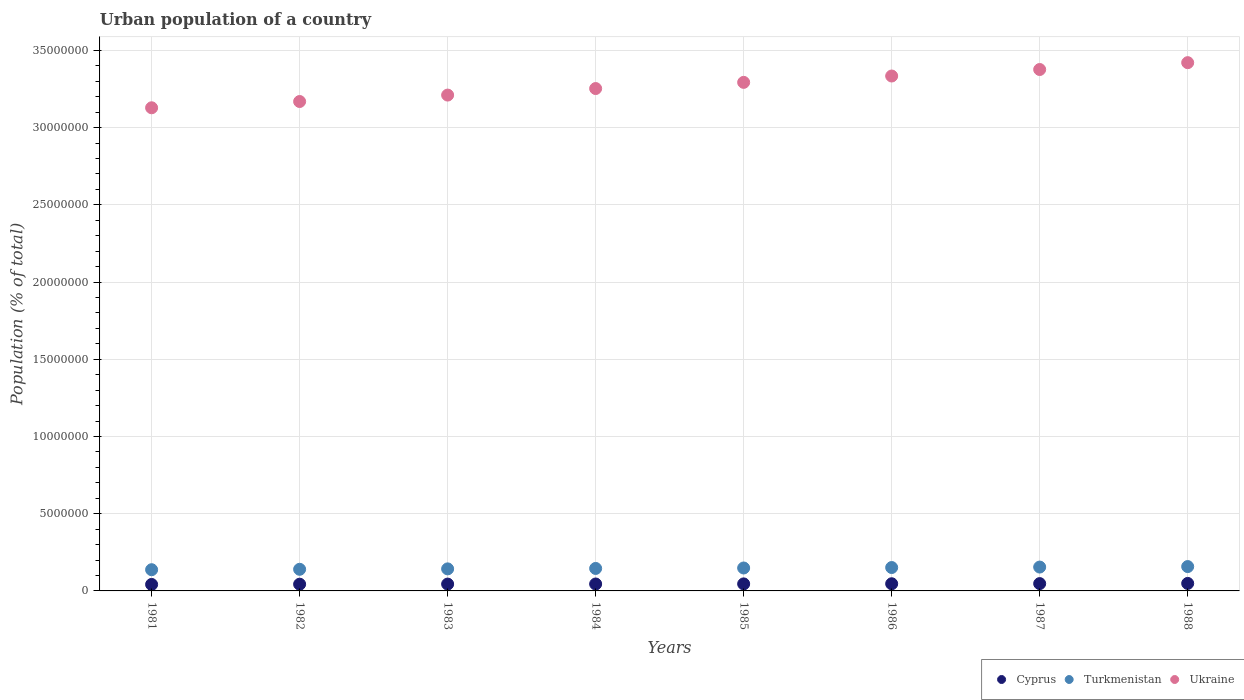How many different coloured dotlines are there?
Your response must be concise. 3. Is the number of dotlines equal to the number of legend labels?
Ensure brevity in your answer.  Yes. What is the urban population in Ukraine in 1985?
Your response must be concise. 3.29e+07. Across all years, what is the maximum urban population in Ukraine?
Your answer should be very brief. 3.42e+07. Across all years, what is the minimum urban population in Ukraine?
Ensure brevity in your answer.  3.13e+07. In which year was the urban population in Turkmenistan maximum?
Make the answer very short. 1988. What is the total urban population in Cyprus in the graph?
Your answer should be compact. 3.62e+06. What is the difference between the urban population in Ukraine in 1982 and that in 1983?
Provide a succinct answer. -4.17e+05. What is the difference between the urban population in Cyprus in 1984 and the urban population in Ukraine in 1988?
Offer a terse response. -3.38e+07. What is the average urban population in Cyprus per year?
Ensure brevity in your answer.  4.53e+05. In the year 1981, what is the difference between the urban population in Cyprus and urban population in Turkmenistan?
Provide a succinct answer. -9.54e+05. What is the ratio of the urban population in Cyprus in 1986 to that in 1988?
Ensure brevity in your answer.  0.95. Is the urban population in Ukraine in 1984 less than that in 1986?
Give a very brief answer. Yes. What is the difference between the highest and the second highest urban population in Ukraine?
Ensure brevity in your answer.  4.43e+05. What is the difference between the highest and the lowest urban population in Ukraine?
Provide a succinct answer. 2.92e+06. Is it the case that in every year, the sum of the urban population in Cyprus and urban population in Turkmenistan  is greater than the urban population in Ukraine?
Provide a short and direct response. No. Does the urban population in Cyprus monotonically increase over the years?
Keep it short and to the point. Yes. How many dotlines are there?
Keep it short and to the point. 3. How many years are there in the graph?
Your answer should be compact. 8. How are the legend labels stacked?
Keep it short and to the point. Horizontal. What is the title of the graph?
Make the answer very short. Urban population of a country. What is the label or title of the X-axis?
Offer a very short reply. Years. What is the label or title of the Y-axis?
Provide a short and direct response. Population (% of total). What is the Population (% of total) in Cyprus in 1981?
Your answer should be very brief. 4.19e+05. What is the Population (% of total) in Turkmenistan in 1981?
Your answer should be very brief. 1.37e+06. What is the Population (% of total) of Ukraine in 1981?
Provide a succinct answer. 3.13e+07. What is the Population (% of total) of Cyprus in 1982?
Ensure brevity in your answer.  4.36e+05. What is the Population (% of total) in Turkmenistan in 1982?
Your response must be concise. 1.40e+06. What is the Population (% of total) of Ukraine in 1982?
Your answer should be compact. 3.17e+07. What is the Population (% of total) of Cyprus in 1983?
Ensure brevity in your answer.  4.43e+05. What is the Population (% of total) in Turkmenistan in 1983?
Offer a terse response. 1.43e+06. What is the Population (% of total) of Ukraine in 1983?
Keep it short and to the point. 3.21e+07. What is the Population (% of total) of Cyprus in 1984?
Make the answer very short. 4.48e+05. What is the Population (% of total) in Turkmenistan in 1984?
Your response must be concise. 1.46e+06. What is the Population (% of total) of Ukraine in 1984?
Your answer should be very brief. 3.25e+07. What is the Population (% of total) of Cyprus in 1985?
Provide a succinct answer. 4.55e+05. What is the Population (% of total) of Turkmenistan in 1985?
Make the answer very short. 1.48e+06. What is the Population (% of total) in Ukraine in 1985?
Offer a terse response. 3.29e+07. What is the Population (% of total) of Cyprus in 1986?
Your answer should be compact. 4.64e+05. What is the Population (% of total) of Turkmenistan in 1986?
Your answer should be compact. 1.51e+06. What is the Population (% of total) in Ukraine in 1986?
Your answer should be very brief. 3.33e+07. What is the Population (% of total) of Cyprus in 1987?
Your answer should be very brief. 4.74e+05. What is the Population (% of total) of Turkmenistan in 1987?
Your answer should be very brief. 1.54e+06. What is the Population (% of total) of Ukraine in 1987?
Provide a short and direct response. 3.38e+07. What is the Population (% of total) of Cyprus in 1988?
Your answer should be compact. 4.86e+05. What is the Population (% of total) of Turkmenistan in 1988?
Keep it short and to the point. 1.58e+06. What is the Population (% of total) in Ukraine in 1988?
Keep it short and to the point. 3.42e+07. Across all years, what is the maximum Population (% of total) of Cyprus?
Offer a very short reply. 4.86e+05. Across all years, what is the maximum Population (% of total) in Turkmenistan?
Give a very brief answer. 1.58e+06. Across all years, what is the maximum Population (% of total) of Ukraine?
Your answer should be compact. 3.42e+07. Across all years, what is the minimum Population (% of total) in Cyprus?
Make the answer very short. 4.19e+05. Across all years, what is the minimum Population (% of total) in Turkmenistan?
Keep it short and to the point. 1.37e+06. Across all years, what is the minimum Population (% of total) of Ukraine?
Ensure brevity in your answer.  3.13e+07. What is the total Population (% of total) of Cyprus in the graph?
Give a very brief answer. 3.62e+06. What is the total Population (% of total) in Turkmenistan in the graph?
Offer a very short reply. 1.18e+07. What is the total Population (% of total) of Ukraine in the graph?
Provide a short and direct response. 2.62e+08. What is the difference between the Population (% of total) in Cyprus in 1981 and that in 1982?
Your answer should be very brief. -1.64e+04. What is the difference between the Population (% of total) of Turkmenistan in 1981 and that in 1982?
Keep it short and to the point. -2.68e+04. What is the difference between the Population (% of total) of Ukraine in 1981 and that in 1982?
Your answer should be very brief. -4.06e+05. What is the difference between the Population (% of total) in Cyprus in 1981 and that in 1983?
Offer a terse response. -2.39e+04. What is the difference between the Population (% of total) of Turkmenistan in 1981 and that in 1983?
Your response must be concise. -5.42e+04. What is the difference between the Population (% of total) of Ukraine in 1981 and that in 1983?
Provide a short and direct response. -8.22e+05. What is the difference between the Population (% of total) of Cyprus in 1981 and that in 1984?
Offer a very short reply. -2.92e+04. What is the difference between the Population (% of total) of Turkmenistan in 1981 and that in 1984?
Ensure brevity in your answer.  -8.22e+04. What is the difference between the Population (% of total) of Ukraine in 1981 and that in 1984?
Provide a short and direct response. -1.25e+06. What is the difference between the Population (% of total) in Cyprus in 1981 and that in 1985?
Keep it short and to the point. -3.61e+04. What is the difference between the Population (% of total) in Turkmenistan in 1981 and that in 1985?
Keep it short and to the point. -1.11e+05. What is the difference between the Population (% of total) of Ukraine in 1981 and that in 1985?
Your answer should be compact. -1.65e+06. What is the difference between the Population (% of total) of Cyprus in 1981 and that in 1986?
Provide a short and direct response. -4.47e+04. What is the difference between the Population (% of total) in Turkmenistan in 1981 and that in 1986?
Your answer should be compact. -1.41e+05. What is the difference between the Population (% of total) in Ukraine in 1981 and that in 1986?
Your response must be concise. -2.06e+06. What is the difference between the Population (% of total) of Cyprus in 1981 and that in 1987?
Provide a succinct answer. -5.49e+04. What is the difference between the Population (% of total) in Turkmenistan in 1981 and that in 1987?
Keep it short and to the point. -1.71e+05. What is the difference between the Population (% of total) in Ukraine in 1981 and that in 1987?
Provide a short and direct response. -2.48e+06. What is the difference between the Population (% of total) of Cyprus in 1981 and that in 1988?
Provide a succinct answer. -6.66e+04. What is the difference between the Population (% of total) of Turkmenistan in 1981 and that in 1988?
Your answer should be compact. -2.03e+05. What is the difference between the Population (% of total) in Ukraine in 1981 and that in 1988?
Offer a terse response. -2.92e+06. What is the difference between the Population (% of total) of Cyprus in 1982 and that in 1983?
Offer a very short reply. -7443. What is the difference between the Population (% of total) in Turkmenistan in 1982 and that in 1983?
Provide a succinct answer. -2.73e+04. What is the difference between the Population (% of total) of Ukraine in 1982 and that in 1983?
Your answer should be compact. -4.17e+05. What is the difference between the Population (% of total) in Cyprus in 1982 and that in 1984?
Your answer should be compact. -1.28e+04. What is the difference between the Population (% of total) of Turkmenistan in 1982 and that in 1984?
Ensure brevity in your answer.  -5.53e+04. What is the difference between the Population (% of total) of Ukraine in 1982 and that in 1984?
Ensure brevity in your answer.  -8.40e+05. What is the difference between the Population (% of total) of Cyprus in 1982 and that in 1985?
Offer a terse response. -1.96e+04. What is the difference between the Population (% of total) in Turkmenistan in 1982 and that in 1985?
Provide a short and direct response. -8.44e+04. What is the difference between the Population (% of total) in Ukraine in 1982 and that in 1985?
Provide a short and direct response. -1.24e+06. What is the difference between the Population (% of total) of Cyprus in 1982 and that in 1986?
Make the answer very short. -2.82e+04. What is the difference between the Population (% of total) in Turkmenistan in 1982 and that in 1986?
Make the answer very short. -1.14e+05. What is the difference between the Population (% of total) of Ukraine in 1982 and that in 1986?
Offer a very short reply. -1.65e+06. What is the difference between the Population (% of total) of Cyprus in 1982 and that in 1987?
Your answer should be very brief. -3.85e+04. What is the difference between the Population (% of total) of Turkmenistan in 1982 and that in 1987?
Make the answer very short. -1.45e+05. What is the difference between the Population (% of total) of Ukraine in 1982 and that in 1987?
Your answer should be very brief. -2.07e+06. What is the difference between the Population (% of total) in Cyprus in 1982 and that in 1988?
Your answer should be very brief. -5.01e+04. What is the difference between the Population (% of total) in Turkmenistan in 1982 and that in 1988?
Offer a terse response. -1.76e+05. What is the difference between the Population (% of total) of Ukraine in 1982 and that in 1988?
Ensure brevity in your answer.  -2.52e+06. What is the difference between the Population (% of total) of Cyprus in 1983 and that in 1984?
Offer a very short reply. -5325. What is the difference between the Population (% of total) in Turkmenistan in 1983 and that in 1984?
Offer a terse response. -2.80e+04. What is the difference between the Population (% of total) in Ukraine in 1983 and that in 1984?
Your answer should be compact. -4.23e+05. What is the difference between the Population (% of total) in Cyprus in 1983 and that in 1985?
Your response must be concise. -1.22e+04. What is the difference between the Population (% of total) in Turkmenistan in 1983 and that in 1985?
Your answer should be very brief. -5.71e+04. What is the difference between the Population (% of total) of Ukraine in 1983 and that in 1985?
Your answer should be compact. -8.23e+05. What is the difference between the Population (% of total) of Cyprus in 1983 and that in 1986?
Give a very brief answer. -2.08e+04. What is the difference between the Population (% of total) in Turkmenistan in 1983 and that in 1986?
Keep it short and to the point. -8.69e+04. What is the difference between the Population (% of total) in Ukraine in 1983 and that in 1986?
Provide a short and direct response. -1.23e+06. What is the difference between the Population (% of total) of Cyprus in 1983 and that in 1987?
Keep it short and to the point. -3.10e+04. What is the difference between the Population (% of total) in Turkmenistan in 1983 and that in 1987?
Ensure brevity in your answer.  -1.17e+05. What is the difference between the Population (% of total) of Ukraine in 1983 and that in 1987?
Provide a short and direct response. -1.66e+06. What is the difference between the Population (% of total) in Cyprus in 1983 and that in 1988?
Provide a succinct answer. -4.27e+04. What is the difference between the Population (% of total) in Turkmenistan in 1983 and that in 1988?
Your answer should be very brief. -1.49e+05. What is the difference between the Population (% of total) of Ukraine in 1983 and that in 1988?
Your answer should be compact. -2.10e+06. What is the difference between the Population (% of total) in Cyprus in 1984 and that in 1985?
Your response must be concise. -6838. What is the difference between the Population (% of total) of Turkmenistan in 1984 and that in 1985?
Provide a short and direct response. -2.90e+04. What is the difference between the Population (% of total) in Ukraine in 1984 and that in 1985?
Give a very brief answer. -4.00e+05. What is the difference between the Population (% of total) of Cyprus in 1984 and that in 1986?
Give a very brief answer. -1.55e+04. What is the difference between the Population (% of total) of Turkmenistan in 1984 and that in 1986?
Provide a succinct answer. -5.88e+04. What is the difference between the Population (% of total) in Ukraine in 1984 and that in 1986?
Give a very brief answer. -8.12e+05. What is the difference between the Population (% of total) in Cyprus in 1984 and that in 1987?
Your answer should be very brief. -2.57e+04. What is the difference between the Population (% of total) in Turkmenistan in 1984 and that in 1987?
Keep it short and to the point. -8.92e+04. What is the difference between the Population (% of total) of Ukraine in 1984 and that in 1987?
Ensure brevity in your answer.  -1.23e+06. What is the difference between the Population (% of total) in Cyprus in 1984 and that in 1988?
Provide a short and direct response. -3.74e+04. What is the difference between the Population (% of total) in Turkmenistan in 1984 and that in 1988?
Make the answer very short. -1.21e+05. What is the difference between the Population (% of total) of Ukraine in 1984 and that in 1988?
Your answer should be very brief. -1.68e+06. What is the difference between the Population (% of total) of Cyprus in 1985 and that in 1986?
Your answer should be very brief. -8613. What is the difference between the Population (% of total) in Turkmenistan in 1985 and that in 1986?
Your answer should be very brief. -2.98e+04. What is the difference between the Population (% of total) in Ukraine in 1985 and that in 1986?
Offer a very short reply. -4.11e+05. What is the difference between the Population (% of total) of Cyprus in 1985 and that in 1987?
Provide a short and direct response. -1.89e+04. What is the difference between the Population (% of total) of Turkmenistan in 1985 and that in 1987?
Your response must be concise. -6.02e+04. What is the difference between the Population (% of total) of Ukraine in 1985 and that in 1987?
Offer a terse response. -8.33e+05. What is the difference between the Population (% of total) of Cyprus in 1985 and that in 1988?
Provide a short and direct response. -3.05e+04. What is the difference between the Population (% of total) of Turkmenistan in 1985 and that in 1988?
Keep it short and to the point. -9.18e+04. What is the difference between the Population (% of total) in Ukraine in 1985 and that in 1988?
Your answer should be very brief. -1.28e+06. What is the difference between the Population (% of total) in Cyprus in 1986 and that in 1987?
Your response must be concise. -1.02e+04. What is the difference between the Population (% of total) of Turkmenistan in 1986 and that in 1987?
Your answer should be compact. -3.04e+04. What is the difference between the Population (% of total) of Ukraine in 1986 and that in 1987?
Keep it short and to the point. -4.21e+05. What is the difference between the Population (% of total) of Cyprus in 1986 and that in 1988?
Keep it short and to the point. -2.19e+04. What is the difference between the Population (% of total) of Turkmenistan in 1986 and that in 1988?
Offer a very short reply. -6.20e+04. What is the difference between the Population (% of total) of Ukraine in 1986 and that in 1988?
Provide a succinct answer. -8.65e+05. What is the difference between the Population (% of total) of Cyprus in 1987 and that in 1988?
Keep it short and to the point. -1.17e+04. What is the difference between the Population (% of total) of Turkmenistan in 1987 and that in 1988?
Provide a short and direct response. -3.16e+04. What is the difference between the Population (% of total) in Ukraine in 1987 and that in 1988?
Offer a very short reply. -4.43e+05. What is the difference between the Population (% of total) in Cyprus in 1981 and the Population (% of total) in Turkmenistan in 1982?
Your response must be concise. -9.81e+05. What is the difference between the Population (% of total) of Cyprus in 1981 and the Population (% of total) of Ukraine in 1982?
Offer a very short reply. -3.13e+07. What is the difference between the Population (% of total) of Turkmenistan in 1981 and the Population (% of total) of Ukraine in 1982?
Your response must be concise. -3.03e+07. What is the difference between the Population (% of total) of Cyprus in 1981 and the Population (% of total) of Turkmenistan in 1983?
Offer a very short reply. -1.01e+06. What is the difference between the Population (% of total) in Cyprus in 1981 and the Population (% of total) in Ukraine in 1983?
Your response must be concise. -3.17e+07. What is the difference between the Population (% of total) of Turkmenistan in 1981 and the Population (% of total) of Ukraine in 1983?
Your answer should be very brief. -3.07e+07. What is the difference between the Population (% of total) in Cyprus in 1981 and the Population (% of total) in Turkmenistan in 1984?
Offer a terse response. -1.04e+06. What is the difference between the Population (% of total) in Cyprus in 1981 and the Population (% of total) in Ukraine in 1984?
Your answer should be very brief. -3.21e+07. What is the difference between the Population (% of total) in Turkmenistan in 1981 and the Population (% of total) in Ukraine in 1984?
Ensure brevity in your answer.  -3.12e+07. What is the difference between the Population (% of total) in Cyprus in 1981 and the Population (% of total) in Turkmenistan in 1985?
Your answer should be very brief. -1.07e+06. What is the difference between the Population (% of total) of Cyprus in 1981 and the Population (% of total) of Ukraine in 1985?
Give a very brief answer. -3.25e+07. What is the difference between the Population (% of total) of Turkmenistan in 1981 and the Population (% of total) of Ukraine in 1985?
Provide a short and direct response. -3.16e+07. What is the difference between the Population (% of total) in Cyprus in 1981 and the Population (% of total) in Turkmenistan in 1986?
Provide a short and direct response. -1.10e+06. What is the difference between the Population (% of total) in Cyprus in 1981 and the Population (% of total) in Ukraine in 1986?
Provide a short and direct response. -3.29e+07. What is the difference between the Population (% of total) of Turkmenistan in 1981 and the Population (% of total) of Ukraine in 1986?
Provide a short and direct response. -3.20e+07. What is the difference between the Population (% of total) of Cyprus in 1981 and the Population (% of total) of Turkmenistan in 1987?
Your answer should be compact. -1.13e+06. What is the difference between the Population (% of total) in Cyprus in 1981 and the Population (% of total) in Ukraine in 1987?
Your answer should be compact. -3.33e+07. What is the difference between the Population (% of total) of Turkmenistan in 1981 and the Population (% of total) of Ukraine in 1987?
Provide a short and direct response. -3.24e+07. What is the difference between the Population (% of total) of Cyprus in 1981 and the Population (% of total) of Turkmenistan in 1988?
Your answer should be very brief. -1.16e+06. What is the difference between the Population (% of total) of Cyprus in 1981 and the Population (% of total) of Ukraine in 1988?
Offer a terse response. -3.38e+07. What is the difference between the Population (% of total) of Turkmenistan in 1981 and the Population (% of total) of Ukraine in 1988?
Keep it short and to the point. -3.28e+07. What is the difference between the Population (% of total) of Cyprus in 1982 and the Population (% of total) of Turkmenistan in 1983?
Offer a terse response. -9.92e+05. What is the difference between the Population (% of total) of Cyprus in 1982 and the Population (% of total) of Ukraine in 1983?
Your answer should be compact. -3.17e+07. What is the difference between the Population (% of total) in Turkmenistan in 1982 and the Population (% of total) in Ukraine in 1983?
Your answer should be very brief. -3.07e+07. What is the difference between the Population (% of total) of Cyprus in 1982 and the Population (% of total) of Turkmenistan in 1984?
Offer a very short reply. -1.02e+06. What is the difference between the Population (% of total) in Cyprus in 1982 and the Population (% of total) in Ukraine in 1984?
Provide a succinct answer. -3.21e+07. What is the difference between the Population (% of total) in Turkmenistan in 1982 and the Population (% of total) in Ukraine in 1984?
Make the answer very short. -3.11e+07. What is the difference between the Population (% of total) of Cyprus in 1982 and the Population (% of total) of Turkmenistan in 1985?
Offer a terse response. -1.05e+06. What is the difference between the Population (% of total) of Cyprus in 1982 and the Population (% of total) of Ukraine in 1985?
Give a very brief answer. -3.25e+07. What is the difference between the Population (% of total) of Turkmenistan in 1982 and the Population (% of total) of Ukraine in 1985?
Provide a succinct answer. -3.15e+07. What is the difference between the Population (% of total) of Cyprus in 1982 and the Population (% of total) of Turkmenistan in 1986?
Keep it short and to the point. -1.08e+06. What is the difference between the Population (% of total) in Cyprus in 1982 and the Population (% of total) in Ukraine in 1986?
Provide a succinct answer. -3.29e+07. What is the difference between the Population (% of total) of Turkmenistan in 1982 and the Population (% of total) of Ukraine in 1986?
Offer a very short reply. -3.19e+07. What is the difference between the Population (% of total) in Cyprus in 1982 and the Population (% of total) in Turkmenistan in 1987?
Your response must be concise. -1.11e+06. What is the difference between the Population (% of total) in Cyprus in 1982 and the Population (% of total) in Ukraine in 1987?
Offer a terse response. -3.33e+07. What is the difference between the Population (% of total) in Turkmenistan in 1982 and the Population (% of total) in Ukraine in 1987?
Offer a very short reply. -3.24e+07. What is the difference between the Population (% of total) of Cyprus in 1982 and the Population (% of total) of Turkmenistan in 1988?
Your answer should be very brief. -1.14e+06. What is the difference between the Population (% of total) in Cyprus in 1982 and the Population (% of total) in Ukraine in 1988?
Your answer should be compact. -3.38e+07. What is the difference between the Population (% of total) of Turkmenistan in 1982 and the Population (% of total) of Ukraine in 1988?
Your response must be concise. -3.28e+07. What is the difference between the Population (% of total) in Cyprus in 1983 and the Population (% of total) in Turkmenistan in 1984?
Your answer should be compact. -1.01e+06. What is the difference between the Population (% of total) of Cyprus in 1983 and the Population (% of total) of Ukraine in 1984?
Your answer should be very brief. -3.21e+07. What is the difference between the Population (% of total) in Turkmenistan in 1983 and the Population (% of total) in Ukraine in 1984?
Keep it short and to the point. -3.11e+07. What is the difference between the Population (% of total) of Cyprus in 1983 and the Population (% of total) of Turkmenistan in 1985?
Your response must be concise. -1.04e+06. What is the difference between the Population (% of total) in Cyprus in 1983 and the Population (% of total) in Ukraine in 1985?
Offer a very short reply. -3.25e+07. What is the difference between the Population (% of total) in Turkmenistan in 1983 and the Population (% of total) in Ukraine in 1985?
Offer a very short reply. -3.15e+07. What is the difference between the Population (% of total) in Cyprus in 1983 and the Population (% of total) in Turkmenistan in 1986?
Offer a terse response. -1.07e+06. What is the difference between the Population (% of total) in Cyprus in 1983 and the Population (% of total) in Ukraine in 1986?
Your answer should be very brief. -3.29e+07. What is the difference between the Population (% of total) of Turkmenistan in 1983 and the Population (% of total) of Ukraine in 1986?
Provide a short and direct response. -3.19e+07. What is the difference between the Population (% of total) of Cyprus in 1983 and the Population (% of total) of Turkmenistan in 1987?
Keep it short and to the point. -1.10e+06. What is the difference between the Population (% of total) of Cyprus in 1983 and the Population (% of total) of Ukraine in 1987?
Offer a terse response. -3.33e+07. What is the difference between the Population (% of total) in Turkmenistan in 1983 and the Population (% of total) in Ukraine in 1987?
Give a very brief answer. -3.23e+07. What is the difference between the Population (% of total) of Cyprus in 1983 and the Population (% of total) of Turkmenistan in 1988?
Offer a terse response. -1.13e+06. What is the difference between the Population (% of total) in Cyprus in 1983 and the Population (% of total) in Ukraine in 1988?
Give a very brief answer. -3.38e+07. What is the difference between the Population (% of total) in Turkmenistan in 1983 and the Population (% of total) in Ukraine in 1988?
Your response must be concise. -3.28e+07. What is the difference between the Population (% of total) in Cyprus in 1984 and the Population (% of total) in Turkmenistan in 1985?
Offer a terse response. -1.04e+06. What is the difference between the Population (% of total) of Cyprus in 1984 and the Population (% of total) of Ukraine in 1985?
Give a very brief answer. -3.25e+07. What is the difference between the Population (% of total) of Turkmenistan in 1984 and the Population (% of total) of Ukraine in 1985?
Provide a short and direct response. -3.15e+07. What is the difference between the Population (% of total) of Cyprus in 1984 and the Population (% of total) of Turkmenistan in 1986?
Provide a succinct answer. -1.07e+06. What is the difference between the Population (% of total) of Cyprus in 1984 and the Population (% of total) of Ukraine in 1986?
Your answer should be compact. -3.29e+07. What is the difference between the Population (% of total) of Turkmenistan in 1984 and the Population (% of total) of Ukraine in 1986?
Ensure brevity in your answer.  -3.19e+07. What is the difference between the Population (% of total) in Cyprus in 1984 and the Population (% of total) in Turkmenistan in 1987?
Offer a terse response. -1.10e+06. What is the difference between the Population (% of total) in Cyprus in 1984 and the Population (% of total) in Ukraine in 1987?
Give a very brief answer. -3.33e+07. What is the difference between the Population (% of total) in Turkmenistan in 1984 and the Population (% of total) in Ukraine in 1987?
Your answer should be very brief. -3.23e+07. What is the difference between the Population (% of total) of Cyprus in 1984 and the Population (% of total) of Turkmenistan in 1988?
Your answer should be very brief. -1.13e+06. What is the difference between the Population (% of total) in Cyprus in 1984 and the Population (% of total) in Ukraine in 1988?
Your answer should be very brief. -3.38e+07. What is the difference between the Population (% of total) of Turkmenistan in 1984 and the Population (% of total) of Ukraine in 1988?
Provide a short and direct response. -3.28e+07. What is the difference between the Population (% of total) of Cyprus in 1985 and the Population (% of total) of Turkmenistan in 1986?
Provide a succinct answer. -1.06e+06. What is the difference between the Population (% of total) in Cyprus in 1985 and the Population (% of total) in Ukraine in 1986?
Give a very brief answer. -3.29e+07. What is the difference between the Population (% of total) of Turkmenistan in 1985 and the Population (% of total) of Ukraine in 1986?
Your answer should be very brief. -3.19e+07. What is the difference between the Population (% of total) in Cyprus in 1985 and the Population (% of total) in Turkmenistan in 1987?
Make the answer very short. -1.09e+06. What is the difference between the Population (% of total) in Cyprus in 1985 and the Population (% of total) in Ukraine in 1987?
Your response must be concise. -3.33e+07. What is the difference between the Population (% of total) in Turkmenistan in 1985 and the Population (% of total) in Ukraine in 1987?
Keep it short and to the point. -3.23e+07. What is the difference between the Population (% of total) in Cyprus in 1985 and the Population (% of total) in Turkmenistan in 1988?
Ensure brevity in your answer.  -1.12e+06. What is the difference between the Population (% of total) in Cyprus in 1985 and the Population (% of total) in Ukraine in 1988?
Give a very brief answer. -3.38e+07. What is the difference between the Population (% of total) in Turkmenistan in 1985 and the Population (% of total) in Ukraine in 1988?
Provide a short and direct response. -3.27e+07. What is the difference between the Population (% of total) in Cyprus in 1986 and the Population (% of total) in Turkmenistan in 1987?
Provide a succinct answer. -1.08e+06. What is the difference between the Population (% of total) of Cyprus in 1986 and the Population (% of total) of Ukraine in 1987?
Give a very brief answer. -3.33e+07. What is the difference between the Population (% of total) of Turkmenistan in 1986 and the Population (% of total) of Ukraine in 1987?
Provide a succinct answer. -3.23e+07. What is the difference between the Population (% of total) in Cyprus in 1986 and the Population (% of total) in Turkmenistan in 1988?
Keep it short and to the point. -1.11e+06. What is the difference between the Population (% of total) of Cyprus in 1986 and the Population (% of total) of Ukraine in 1988?
Offer a terse response. -3.37e+07. What is the difference between the Population (% of total) of Turkmenistan in 1986 and the Population (% of total) of Ukraine in 1988?
Ensure brevity in your answer.  -3.27e+07. What is the difference between the Population (% of total) of Cyprus in 1987 and the Population (% of total) of Turkmenistan in 1988?
Ensure brevity in your answer.  -1.10e+06. What is the difference between the Population (% of total) of Cyprus in 1987 and the Population (% of total) of Ukraine in 1988?
Make the answer very short. -3.37e+07. What is the difference between the Population (% of total) of Turkmenistan in 1987 and the Population (% of total) of Ukraine in 1988?
Give a very brief answer. -3.27e+07. What is the average Population (% of total) in Cyprus per year?
Give a very brief answer. 4.53e+05. What is the average Population (% of total) of Turkmenistan per year?
Offer a very short reply. 1.47e+06. What is the average Population (% of total) in Ukraine per year?
Provide a short and direct response. 3.27e+07. In the year 1981, what is the difference between the Population (% of total) in Cyprus and Population (% of total) in Turkmenistan?
Ensure brevity in your answer.  -9.54e+05. In the year 1981, what is the difference between the Population (% of total) in Cyprus and Population (% of total) in Ukraine?
Provide a succinct answer. -3.09e+07. In the year 1981, what is the difference between the Population (% of total) in Turkmenistan and Population (% of total) in Ukraine?
Your response must be concise. -2.99e+07. In the year 1982, what is the difference between the Population (% of total) in Cyprus and Population (% of total) in Turkmenistan?
Provide a short and direct response. -9.65e+05. In the year 1982, what is the difference between the Population (% of total) of Cyprus and Population (% of total) of Ukraine?
Give a very brief answer. -3.13e+07. In the year 1982, what is the difference between the Population (% of total) of Turkmenistan and Population (% of total) of Ukraine?
Offer a very short reply. -3.03e+07. In the year 1983, what is the difference between the Population (% of total) in Cyprus and Population (% of total) in Turkmenistan?
Offer a terse response. -9.85e+05. In the year 1983, what is the difference between the Population (% of total) in Cyprus and Population (% of total) in Ukraine?
Keep it short and to the point. -3.17e+07. In the year 1983, what is the difference between the Population (% of total) in Turkmenistan and Population (% of total) in Ukraine?
Your response must be concise. -3.07e+07. In the year 1984, what is the difference between the Population (% of total) in Cyprus and Population (% of total) in Turkmenistan?
Your answer should be very brief. -1.01e+06. In the year 1984, what is the difference between the Population (% of total) in Cyprus and Population (% of total) in Ukraine?
Ensure brevity in your answer.  -3.21e+07. In the year 1984, what is the difference between the Population (% of total) of Turkmenistan and Population (% of total) of Ukraine?
Provide a succinct answer. -3.11e+07. In the year 1985, what is the difference between the Population (% of total) of Cyprus and Population (% of total) of Turkmenistan?
Your answer should be very brief. -1.03e+06. In the year 1985, what is the difference between the Population (% of total) of Cyprus and Population (% of total) of Ukraine?
Offer a terse response. -3.25e+07. In the year 1985, what is the difference between the Population (% of total) of Turkmenistan and Population (% of total) of Ukraine?
Provide a succinct answer. -3.14e+07. In the year 1986, what is the difference between the Population (% of total) in Cyprus and Population (% of total) in Turkmenistan?
Offer a terse response. -1.05e+06. In the year 1986, what is the difference between the Population (% of total) in Cyprus and Population (% of total) in Ukraine?
Your response must be concise. -3.29e+07. In the year 1986, what is the difference between the Population (% of total) of Turkmenistan and Population (% of total) of Ukraine?
Ensure brevity in your answer.  -3.18e+07. In the year 1987, what is the difference between the Population (% of total) of Cyprus and Population (% of total) of Turkmenistan?
Your answer should be compact. -1.07e+06. In the year 1987, what is the difference between the Population (% of total) of Cyprus and Population (% of total) of Ukraine?
Offer a terse response. -3.33e+07. In the year 1987, what is the difference between the Population (% of total) of Turkmenistan and Population (% of total) of Ukraine?
Your response must be concise. -3.22e+07. In the year 1988, what is the difference between the Population (% of total) of Cyprus and Population (% of total) of Turkmenistan?
Your response must be concise. -1.09e+06. In the year 1988, what is the difference between the Population (% of total) in Cyprus and Population (% of total) in Ukraine?
Your answer should be very brief. -3.37e+07. In the year 1988, what is the difference between the Population (% of total) in Turkmenistan and Population (% of total) in Ukraine?
Give a very brief answer. -3.26e+07. What is the ratio of the Population (% of total) in Cyprus in 1981 to that in 1982?
Your answer should be very brief. 0.96. What is the ratio of the Population (% of total) of Turkmenistan in 1981 to that in 1982?
Offer a very short reply. 0.98. What is the ratio of the Population (% of total) in Ukraine in 1981 to that in 1982?
Give a very brief answer. 0.99. What is the ratio of the Population (% of total) in Cyprus in 1981 to that in 1983?
Keep it short and to the point. 0.95. What is the ratio of the Population (% of total) in Turkmenistan in 1981 to that in 1983?
Your answer should be very brief. 0.96. What is the ratio of the Population (% of total) in Ukraine in 1981 to that in 1983?
Your answer should be very brief. 0.97. What is the ratio of the Population (% of total) of Cyprus in 1981 to that in 1984?
Your answer should be compact. 0.93. What is the ratio of the Population (% of total) in Turkmenistan in 1981 to that in 1984?
Make the answer very short. 0.94. What is the ratio of the Population (% of total) in Ukraine in 1981 to that in 1984?
Provide a succinct answer. 0.96. What is the ratio of the Population (% of total) in Cyprus in 1981 to that in 1985?
Your answer should be very brief. 0.92. What is the ratio of the Population (% of total) of Turkmenistan in 1981 to that in 1985?
Make the answer very short. 0.93. What is the ratio of the Population (% of total) in Cyprus in 1981 to that in 1986?
Ensure brevity in your answer.  0.9. What is the ratio of the Population (% of total) in Turkmenistan in 1981 to that in 1986?
Make the answer very short. 0.91. What is the ratio of the Population (% of total) in Ukraine in 1981 to that in 1986?
Offer a terse response. 0.94. What is the ratio of the Population (% of total) in Cyprus in 1981 to that in 1987?
Offer a terse response. 0.88. What is the ratio of the Population (% of total) in Turkmenistan in 1981 to that in 1987?
Provide a succinct answer. 0.89. What is the ratio of the Population (% of total) in Ukraine in 1981 to that in 1987?
Provide a short and direct response. 0.93. What is the ratio of the Population (% of total) in Cyprus in 1981 to that in 1988?
Offer a very short reply. 0.86. What is the ratio of the Population (% of total) of Turkmenistan in 1981 to that in 1988?
Offer a very short reply. 0.87. What is the ratio of the Population (% of total) of Ukraine in 1981 to that in 1988?
Your response must be concise. 0.91. What is the ratio of the Population (% of total) of Cyprus in 1982 to that in 1983?
Your answer should be very brief. 0.98. What is the ratio of the Population (% of total) in Turkmenistan in 1982 to that in 1983?
Keep it short and to the point. 0.98. What is the ratio of the Population (% of total) of Ukraine in 1982 to that in 1983?
Make the answer very short. 0.99. What is the ratio of the Population (% of total) of Cyprus in 1982 to that in 1984?
Keep it short and to the point. 0.97. What is the ratio of the Population (% of total) in Ukraine in 1982 to that in 1984?
Provide a succinct answer. 0.97. What is the ratio of the Population (% of total) of Cyprus in 1982 to that in 1985?
Offer a very short reply. 0.96. What is the ratio of the Population (% of total) of Turkmenistan in 1982 to that in 1985?
Make the answer very short. 0.94. What is the ratio of the Population (% of total) in Ukraine in 1982 to that in 1985?
Ensure brevity in your answer.  0.96. What is the ratio of the Population (% of total) in Cyprus in 1982 to that in 1986?
Your answer should be very brief. 0.94. What is the ratio of the Population (% of total) in Turkmenistan in 1982 to that in 1986?
Make the answer very short. 0.92. What is the ratio of the Population (% of total) in Ukraine in 1982 to that in 1986?
Provide a short and direct response. 0.95. What is the ratio of the Population (% of total) in Cyprus in 1982 to that in 1987?
Provide a succinct answer. 0.92. What is the ratio of the Population (% of total) in Turkmenistan in 1982 to that in 1987?
Your response must be concise. 0.91. What is the ratio of the Population (% of total) of Ukraine in 1982 to that in 1987?
Your answer should be very brief. 0.94. What is the ratio of the Population (% of total) in Cyprus in 1982 to that in 1988?
Keep it short and to the point. 0.9. What is the ratio of the Population (% of total) of Turkmenistan in 1982 to that in 1988?
Provide a short and direct response. 0.89. What is the ratio of the Population (% of total) of Ukraine in 1982 to that in 1988?
Offer a terse response. 0.93. What is the ratio of the Population (% of total) in Turkmenistan in 1983 to that in 1984?
Make the answer very short. 0.98. What is the ratio of the Population (% of total) of Ukraine in 1983 to that in 1984?
Ensure brevity in your answer.  0.99. What is the ratio of the Population (% of total) of Cyprus in 1983 to that in 1985?
Keep it short and to the point. 0.97. What is the ratio of the Population (% of total) of Turkmenistan in 1983 to that in 1985?
Make the answer very short. 0.96. What is the ratio of the Population (% of total) in Cyprus in 1983 to that in 1986?
Ensure brevity in your answer.  0.96. What is the ratio of the Population (% of total) of Turkmenistan in 1983 to that in 1986?
Your answer should be very brief. 0.94. What is the ratio of the Population (% of total) in Ukraine in 1983 to that in 1986?
Keep it short and to the point. 0.96. What is the ratio of the Population (% of total) in Cyprus in 1983 to that in 1987?
Ensure brevity in your answer.  0.93. What is the ratio of the Population (% of total) in Turkmenistan in 1983 to that in 1987?
Your response must be concise. 0.92. What is the ratio of the Population (% of total) in Ukraine in 1983 to that in 1987?
Provide a succinct answer. 0.95. What is the ratio of the Population (% of total) in Cyprus in 1983 to that in 1988?
Give a very brief answer. 0.91. What is the ratio of the Population (% of total) of Turkmenistan in 1983 to that in 1988?
Provide a succinct answer. 0.91. What is the ratio of the Population (% of total) in Ukraine in 1983 to that in 1988?
Your response must be concise. 0.94. What is the ratio of the Population (% of total) of Turkmenistan in 1984 to that in 1985?
Keep it short and to the point. 0.98. What is the ratio of the Population (% of total) of Cyprus in 1984 to that in 1986?
Your answer should be very brief. 0.97. What is the ratio of the Population (% of total) of Turkmenistan in 1984 to that in 1986?
Offer a terse response. 0.96. What is the ratio of the Population (% of total) in Ukraine in 1984 to that in 1986?
Offer a very short reply. 0.98. What is the ratio of the Population (% of total) of Cyprus in 1984 to that in 1987?
Provide a succinct answer. 0.95. What is the ratio of the Population (% of total) in Turkmenistan in 1984 to that in 1987?
Make the answer very short. 0.94. What is the ratio of the Population (% of total) of Ukraine in 1984 to that in 1987?
Make the answer very short. 0.96. What is the ratio of the Population (% of total) of Cyprus in 1984 to that in 1988?
Make the answer very short. 0.92. What is the ratio of the Population (% of total) of Turkmenistan in 1984 to that in 1988?
Provide a short and direct response. 0.92. What is the ratio of the Population (% of total) of Ukraine in 1984 to that in 1988?
Provide a short and direct response. 0.95. What is the ratio of the Population (% of total) in Cyprus in 1985 to that in 1986?
Offer a very short reply. 0.98. What is the ratio of the Population (% of total) of Turkmenistan in 1985 to that in 1986?
Provide a succinct answer. 0.98. What is the ratio of the Population (% of total) in Ukraine in 1985 to that in 1986?
Keep it short and to the point. 0.99. What is the ratio of the Population (% of total) of Cyprus in 1985 to that in 1987?
Provide a short and direct response. 0.96. What is the ratio of the Population (% of total) of Ukraine in 1985 to that in 1987?
Your answer should be very brief. 0.98. What is the ratio of the Population (% of total) in Cyprus in 1985 to that in 1988?
Provide a short and direct response. 0.94. What is the ratio of the Population (% of total) in Turkmenistan in 1985 to that in 1988?
Your response must be concise. 0.94. What is the ratio of the Population (% of total) in Ukraine in 1985 to that in 1988?
Provide a succinct answer. 0.96. What is the ratio of the Population (% of total) in Cyprus in 1986 to that in 1987?
Give a very brief answer. 0.98. What is the ratio of the Population (% of total) in Turkmenistan in 1986 to that in 1987?
Provide a short and direct response. 0.98. What is the ratio of the Population (% of total) of Ukraine in 1986 to that in 1987?
Offer a terse response. 0.99. What is the ratio of the Population (% of total) of Cyprus in 1986 to that in 1988?
Your answer should be compact. 0.95. What is the ratio of the Population (% of total) of Turkmenistan in 1986 to that in 1988?
Offer a terse response. 0.96. What is the ratio of the Population (% of total) of Ukraine in 1986 to that in 1988?
Ensure brevity in your answer.  0.97. What is the ratio of the Population (% of total) in Cyprus in 1987 to that in 1988?
Your answer should be very brief. 0.98. What is the ratio of the Population (% of total) of Turkmenistan in 1987 to that in 1988?
Ensure brevity in your answer.  0.98. What is the ratio of the Population (% of total) in Ukraine in 1987 to that in 1988?
Your response must be concise. 0.99. What is the difference between the highest and the second highest Population (% of total) of Cyprus?
Provide a short and direct response. 1.17e+04. What is the difference between the highest and the second highest Population (% of total) of Turkmenistan?
Ensure brevity in your answer.  3.16e+04. What is the difference between the highest and the second highest Population (% of total) of Ukraine?
Your answer should be very brief. 4.43e+05. What is the difference between the highest and the lowest Population (% of total) in Cyprus?
Offer a terse response. 6.66e+04. What is the difference between the highest and the lowest Population (% of total) of Turkmenistan?
Make the answer very short. 2.03e+05. What is the difference between the highest and the lowest Population (% of total) in Ukraine?
Your response must be concise. 2.92e+06. 